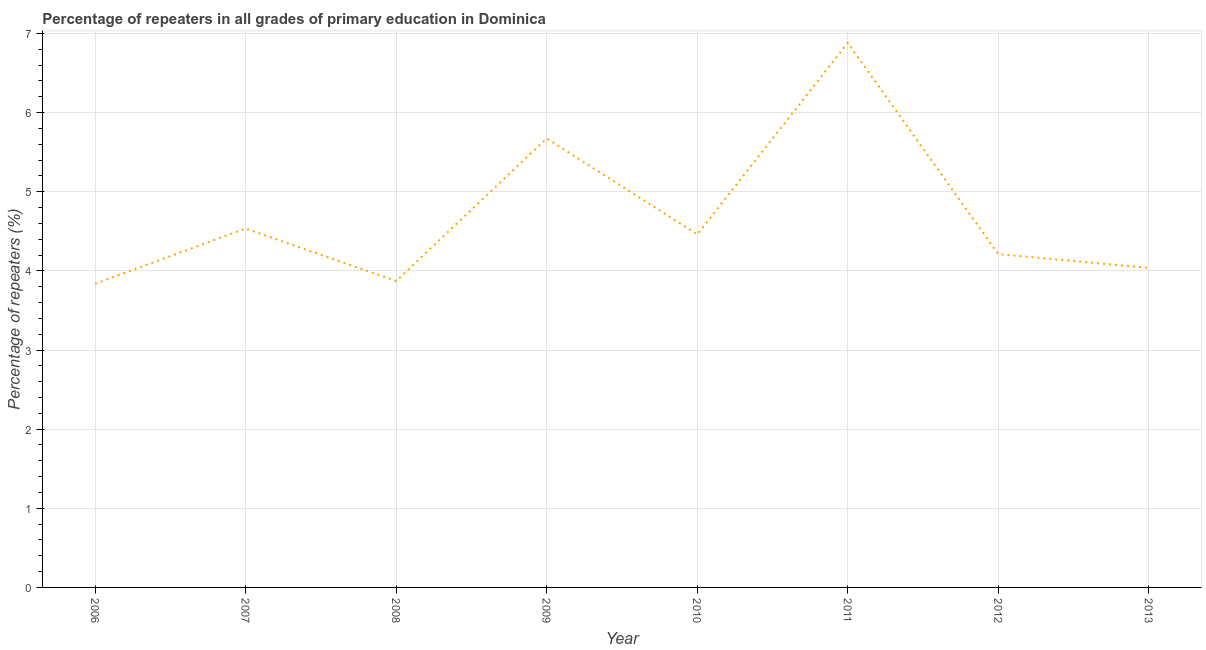What is the percentage of repeaters in primary education in 2010?
Provide a short and direct response. 4.46. Across all years, what is the maximum percentage of repeaters in primary education?
Keep it short and to the point. 6.88. Across all years, what is the minimum percentage of repeaters in primary education?
Provide a succinct answer. 3.84. In which year was the percentage of repeaters in primary education maximum?
Provide a short and direct response. 2011. What is the sum of the percentage of repeaters in primary education?
Give a very brief answer. 37.51. What is the difference between the percentage of repeaters in primary education in 2006 and 2007?
Ensure brevity in your answer.  -0.7. What is the average percentage of repeaters in primary education per year?
Provide a short and direct response. 4.69. What is the median percentage of repeaters in primary education?
Provide a short and direct response. 4.34. What is the ratio of the percentage of repeaters in primary education in 2008 to that in 2011?
Your answer should be very brief. 0.56. What is the difference between the highest and the second highest percentage of repeaters in primary education?
Offer a very short reply. 1.21. Is the sum of the percentage of repeaters in primary education in 2010 and 2011 greater than the maximum percentage of repeaters in primary education across all years?
Your answer should be very brief. Yes. What is the difference between the highest and the lowest percentage of repeaters in primary education?
Offer a terse response. 3.04. Does the percentage of repeaters in primary education monotonically increase over the years?
Ensure brevity in your answer.  No. How many lines are there?
Make the answer very short. 1. How many years are there in the graph?
Your response must be concise. 8. What is the difference between two consecutive major ticks on the Y-axis?
Give a very brief answer. 1. Are the values on the major ticks of Y-axis written in scientific E-notation?
Offer a very short reply. No. Does the graph contain any zero values?
Ensure brevity in your answer.  No. Does the graph contain grids?
Your answer should be compact. Yes. What is the title of the graph?
Provide a short and direct response. Percentage of repeaters in all grades of primary education in Dominica. What is the label or title of the Y-axis?
Keep it short and to the point. Percentage of repeaters (%). What is the Percentage of repeaters (%) of 2006?
Provide a succinct answer. 3.84. What is the Percentage of repeaters (%) in 2007?
Your response must be concise. 4.54. What is the Percentage of repeaters (%) of 2008?
Ensure brevity in your answer.  3.87. What is the Percentage of repeaters (%) in 2009?
Give a very brief answer. 5.67. What is the Percentage of repeaters (%) in 2010?
Give a very brief answer. 4.46. What is the Percentage of repeaters (%) in 2011?
Your answer should be very brief. 6.88. What is the Percentage of repeaters (%) of 2012?
Provide a short and direct response. 4.21. What is the Percentage of repeaters (%) of 2013?
Your answer should be very brief. 4.04. What is the difference between the Percentage of repeaters (%) in 2006 and 2007?
Ensure brevity in your answer.  -0.7. What is the difference between the Percentage of repeaters (%) in 2006 and 2008?
Give a very brief answer. -0.03. What is the difference between the Percentage of repeaters (%) in 2006 and 2009?
Your answer should be very brief. -1.84. What is the difference between the Percentage of repeaters (%) in 2006 and 2010?
Make the answer very short. -0.62. What is the difference between the Percentage of repeaters (%) in 2006 and 2011?
Make the answer very short. -3.04. What is the difference between the Percentage of repeaters (%) in 2006 and 2012?
Make the answer very short. -0.37. What is the difference between the Percentage of repeaters (%) in 2006 and 2013?
Make the answer very short. -0.2. What is the difference between the Percentage of repeaters (%) in 2007 and 2008?
Provide a succinct answer. 0.66. What is the difference between the Percentage of repeaters (%) in 2007 and 2009?
Offer a very short reply. -1.14. What is the difference between the Percentage of repeaters (%) in 2007 and 2010?
Keep it short and to the point. 0.07. What is the difference between the Percentage of repeaters (%) in 2007 and 2011?
Keep it short and to the point. -2.35. What is the difference between the Percentage of repeaters (%) in 2007 and 2012?
Your response must be concise. 0.32. What is the difference between the Percentage of repeaters (%) in 2007 and 2013?
Your response must be concise. 0.5. What is the difference between the Percentage of repeaters (%) in 2008 and 2009?
Give a very brief answer. -1.8. What is the difference between the Percentage of repeaters (%) in 2008 and 2010?
Offer a terse response. -0.59. What is the difference between the Percentage of repeaters (%) in 2008 and 2011?
Your answer should be compact. -3.01. What is the difference between the Percentage of repeaters (%) in 2008 and 2012?
Keep it short and to the point. -0.34. What is the difference between the Percentage of repeaters (%) in 2008 and 2013?
Provide a succinct answer. -0.17. What is the difference between the Percentage of repeaters (%) in 2009 and 2010?
Ensure brevity in your answer.  1.21. What is the difference between the Percentage of repeaters (%) in 2009 and 2011?
Offer a terse response. -1.21. What is the difference between the Percentage of repeaters (%) in 2009 and 2012?
Give a very brief answer. 1.46. What is the difference between the Percentage of repeaters (%) in 2009 and 2013?
Your answer should be compact. 1.64. What is the difference between the Percentage of repeaters (%) in 2010 and 2011?
Offer a terse response. -2.42. What is the difference between the Percentage of repeaters (%) in 2010 and 2012?
Offer a terse response. 0.25. What is the difference between the Percentage of repeaters (%) in 2010 and 2013?
Provide a short and direct response. 0.42. What is the difference between the Percentage of repeaters (%) in 2011 and 2012?
Give a very brief answer. 2.67. What is the difference between the Percentage of repeaters (%) in 2011 and 2013?
Give a very brief answer. 2.84. What is the difference between the Percentage of repeaters (%) in 2012 and 2013?
Provide a succinct answer. 0.17. What is the ratio of the Percentage of repeaters (%) in 2006 to that in 2007?
Ensure brevity in your answer.  0.85. What is the ratio of the Percentage of repeaters (%) in 2006 to that in 2009?
Your answer should be very brief. 0.68. What is the ratio of the Percentage of repeaters (%) in 2006 to that in 2010?
Ensure brevity in your answer.  0.86. What is the ratio of the Percentage of repeaters (%) in 2006 to that in 2011?
Provide a short and direct response. 0.56. What is the ratio of the Percentage of repeaters (%) in 2006 to that in 2012?
Your response must be concise. 0.91. What is the ratio of the Percentage of repeaters (%) in 2006 to that in 2013?
Keep it short and to the point. 0.95. What is the ratio of the Percentage of repeaters (%) in 2007 to that in 2008?
Keep it short and to the point. 1.17. What is the ratio of the Percentage of repeaters (%) in 2007 to that in 2009?
Give a very brief answer. 0.8. What is the ratio of the Percentage of repeaters (%) in 2007 to that in 2010?
Provide a short and direct response. 1.02. What is the ratio of the Percentage of repeaters (%) in 2007 to that in 2011?
Offer a terse response. 0.66. What is the ratio of the Percentage of repeaters (%) in 2007 to that in 2012?
Offer a very short reply. 1.08. What is the ratio of the Percentage of repeaters (%) in 2007 to that in 2013?
Your response must be concise. 1.12. What is the ratio of the Percentage of repeaters (%) in 2008 to that in 2009?
Offer a very short reply. 0.68. What is the ratio of the Percentage of repeaters (%) in 2008 to that in 2010?
Provide a succinct answer. 0.87. What is the ratio of the Percentage of repeaters (%) in 2008 to that in 2011?
Provide a short and direct response. 0.56. What is the ratio of the Percentage of repeaters (%) in 2008 to that in 2012?
Ensure brevity in your answer.  0.92. What is the ratio of the Percentage of repeaters (%) in 2008 to that in 2013?
Provide a succinct answer. 0.96. What is the ratio of the Percentage of repeaters (%) in 2009 to that in 2010?
Give a very brief answer. 1.27. What is the ratio of the Percentage of repeaters (%) in 2009 to that in 2011?
Offer a very short reply. 0.82. What is the ratio of the Percentage of repeaters (%) in 2009 to that in 2012?
Give a very brief answer. 1.35. What is the ratio of the Percentage of repeaters (%) in 2009 to that in 2013?
Ensure brevity in your answer.  1.41. What is the ratio of the Percentage of repeaters (%) in 2010 to that in 2011?
Provide a succinct answer. 0.65. What is the ratio of the Percentage of repeaters (%) in 2010 to that in 2012?
Provide a succinct answer. 1.06. What is the ratio of the Percentage of repeaters (%) in 2010 to that in 2013?
Offer a very short reply. 1.1. What is the ratio of the Percentage of repeaters (%) in 2011 to that in 2012?
Make the answer very short. 1.63. What is the ratio of the Percentage of repeaters (%) in 2011 to that in 2013?
Provide a succinct answer. 1.7. What is the ratio of the Percentage of repeaters (%) in 2012 to that in 2013?
Provide a succinct answer. 1.04. 